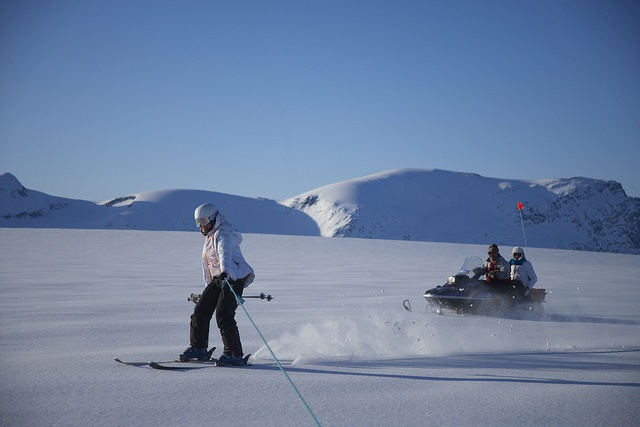Describe the objects in this image and their specific colors. I can see people in blue, black, darkgray, and gray tones, people in blue, black, darkblue, navy, and gray tones, people in blue, black, navy, gray, and maroon tones, and skis in blue, darkgray, gray, and black tones in this image. 